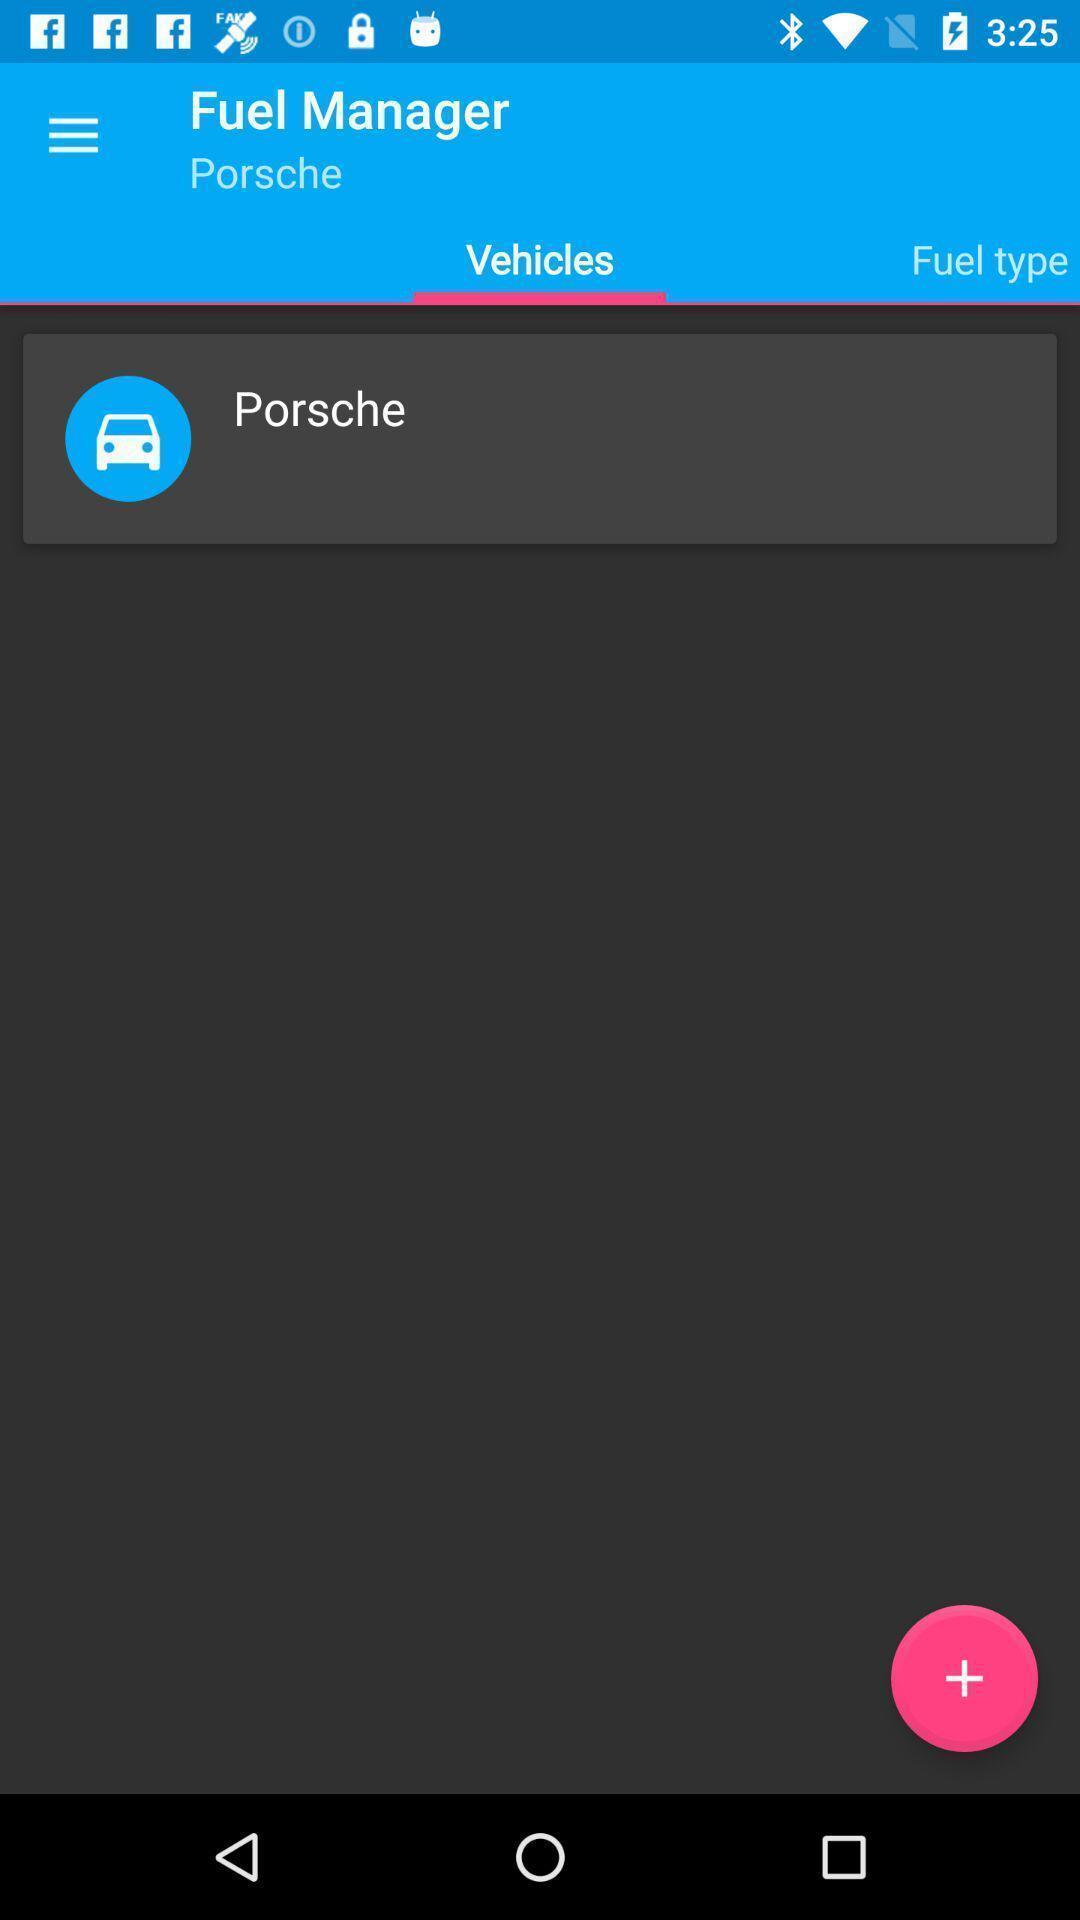Give me a summary of this screen capture. Page displaying different information about fuel for different vehicles. 